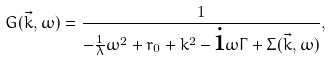<formula> <loc_0><loc_0><loc_500><loc_500>G ( \vec { k } , \omega ) = \frac { 1 } { - \frac { 1 } { \lambda } \omega ^ { 2 } + r _ { 0 } + k ^ { 2 } - \text {i} \omega \Gamma + \Sigma ( \vec { k } , \omega ) } ,</formula> 